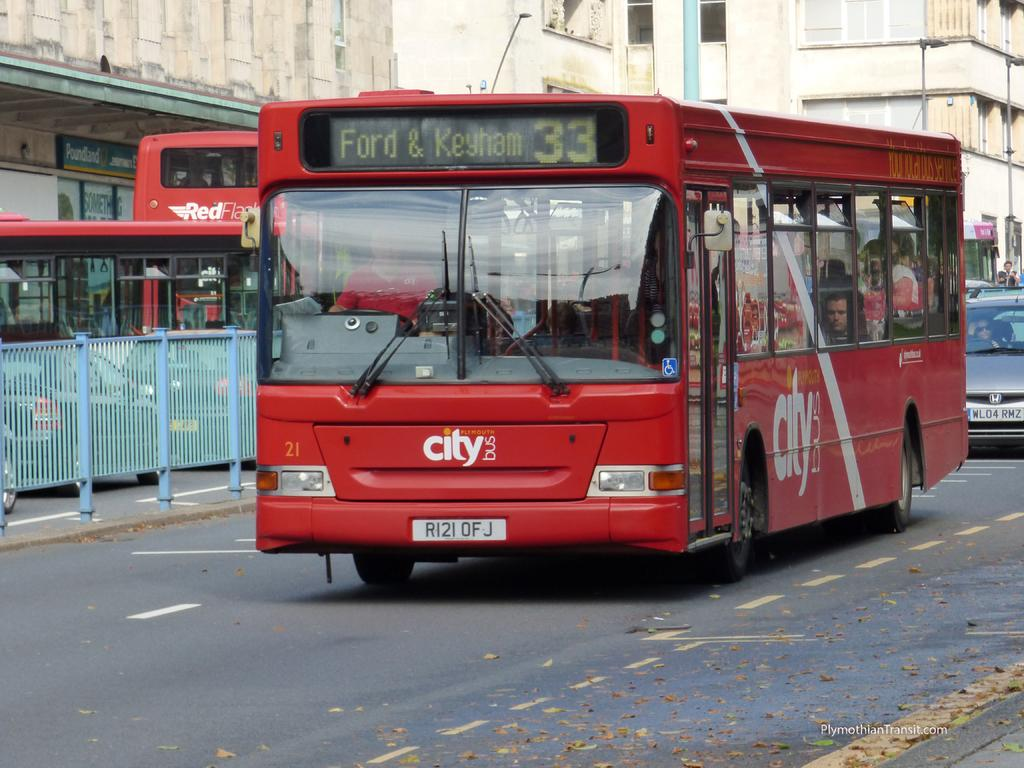What type of vehicle can be seen on the road in the image? There is a bus on the road in the image. What other type of vehicle is present on the road? There is a car on the road in the image. What can be seen in the background of the image? There is a fence and buildings in the background of the image. What is the order of the planets in the image? There are no planets present in the image; it features a bus, a car, a fence, and buildings. 